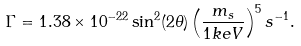<formula> <loc_0><loc_0><loc_500><loc_500>\Gamma = 1 . 3 8 \times 1 0 ^ { - 2 2 } \sin ^ { 2 } ( 2 \theta ) \left ( \frac { m _ { s } } { 1 k e V } \right ) ^ { 5 } s ^ { - 1 } .</formula> 